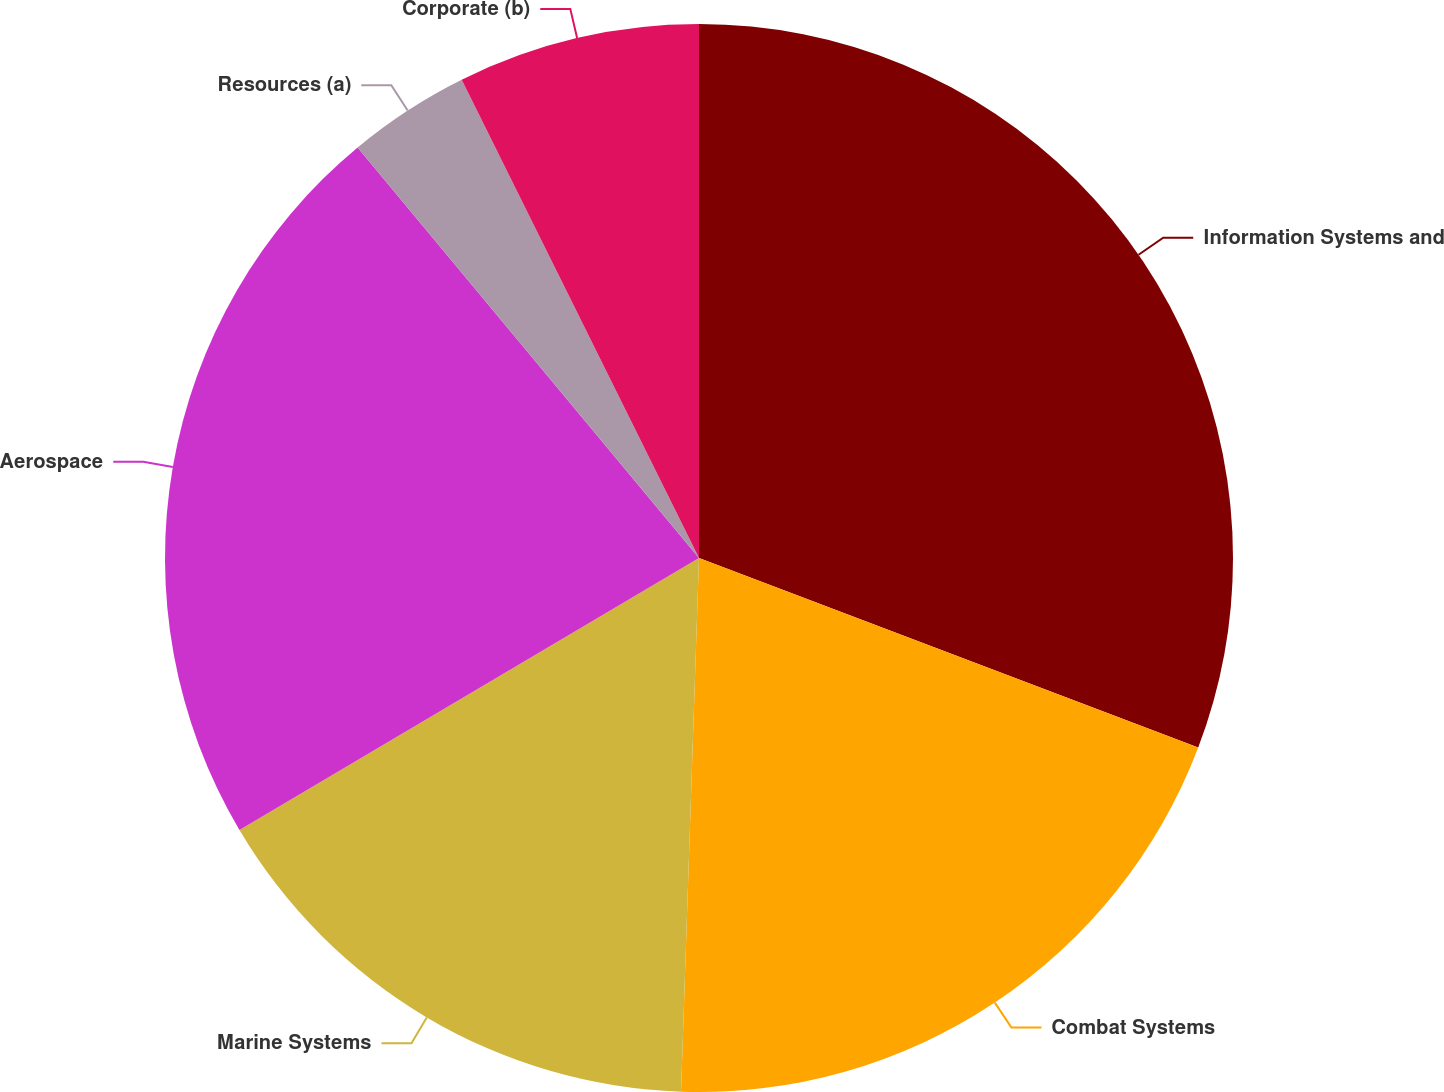Convert chart. <chart><loc_0><loc_0><loc_500><loc_500><pie_chart><fcel>Information Systems and<fcel>Combat Systems<fcel>Marine Systems<fcel>Aerospace<fcel>Resources (a)<fcel>Corporate (b)<nl><fcel>30.78%<fcel>19.76%<fcel>15.96%<fcel>22.47%<fcel>3.71%<fcel>7.33%<nl></chart> 